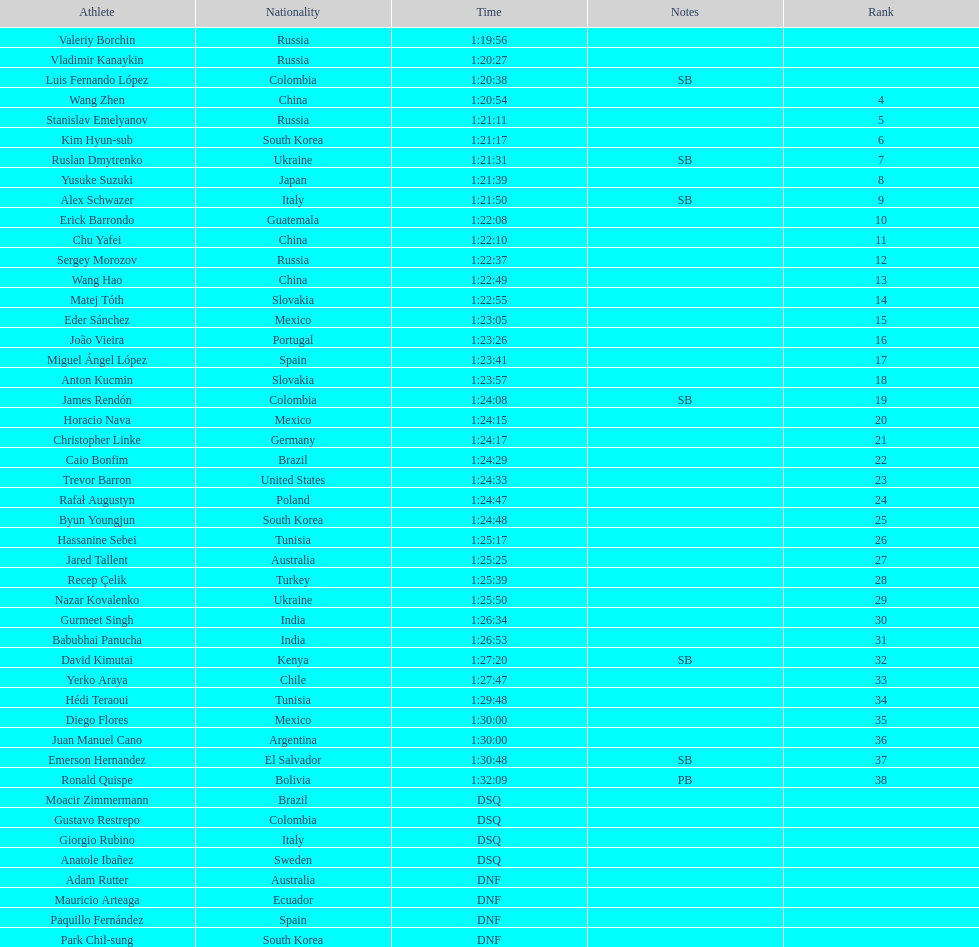Which chinese athlete had the fastest time? Wang Zhen. 